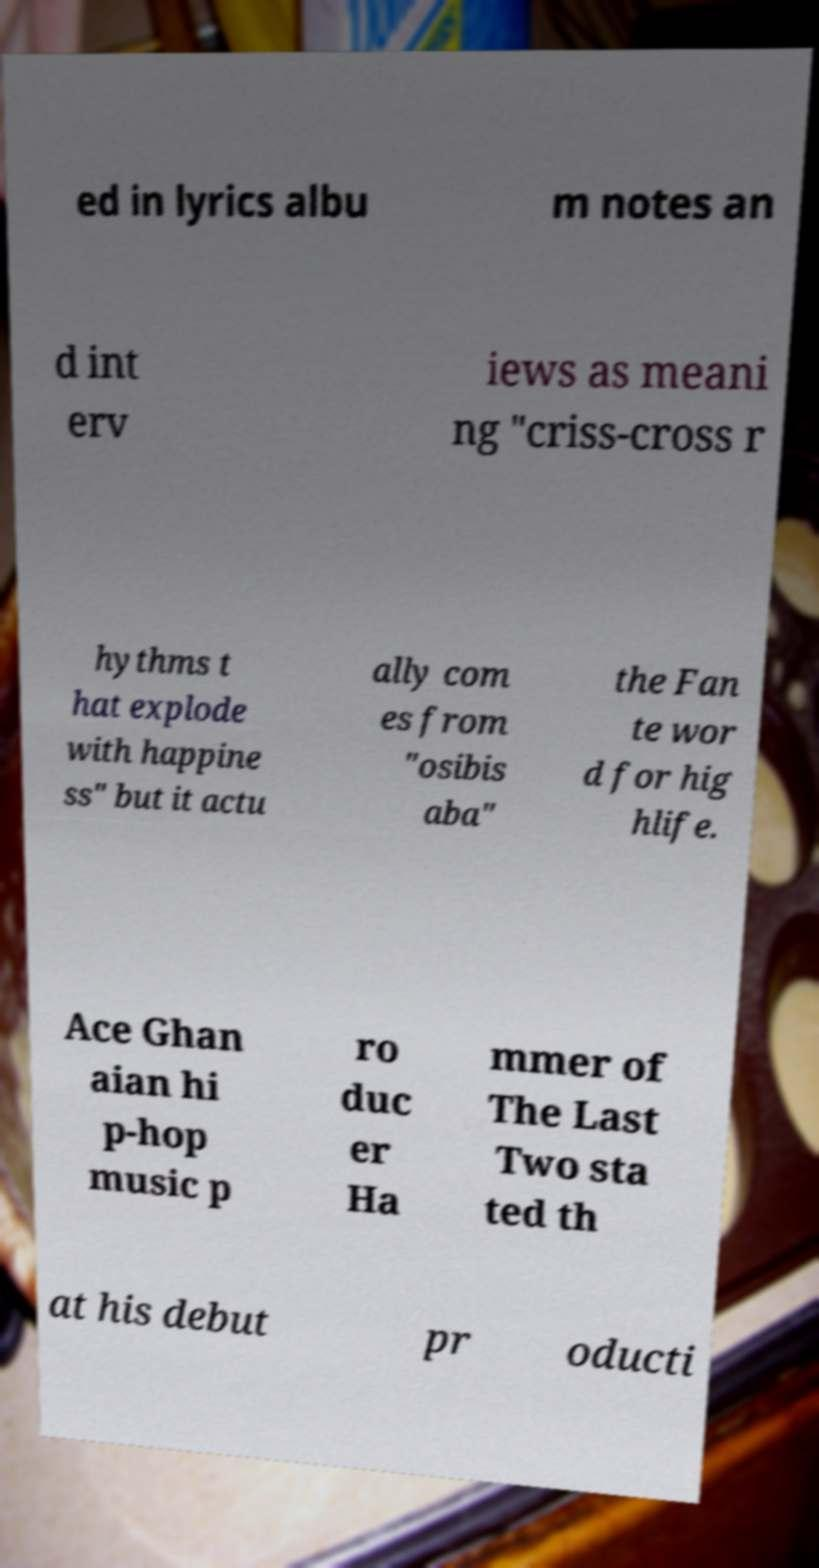Can you read and provide the text displayed in the image?This photo seems to have some interesting text. Can you extract and type it out for me? ed in lyrics albu m notes an d int erv iews as meani ng "criss-cross r hythms t hat explode with happine ss" but it actu ally com es from "osibis aba" the Fan te wor d for hig hlife. Ace Ghan aian hi p-hop music p ro duc er Ha mmer of The Last Two sta ted th at his debut pr oducti 